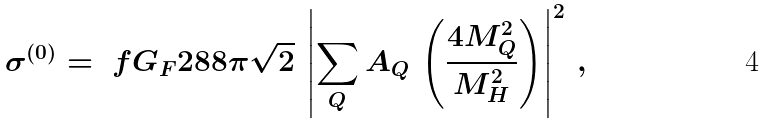<formula> <loc_0><loc_0><loc_500><loc_500>\sigma ^ { ( 0 ) } = \ f { G _ { F } } { 2 8 8 \pi \sqrt { 2 } } \, \left | \sum _ { Q } A _ { Q } \, \left ( \frac { 4 M _ { Q } ^ { 2 } } { M _ { H } ^ { 2 } } \right ) \right | ^ { 2 } \, ,</formula> 